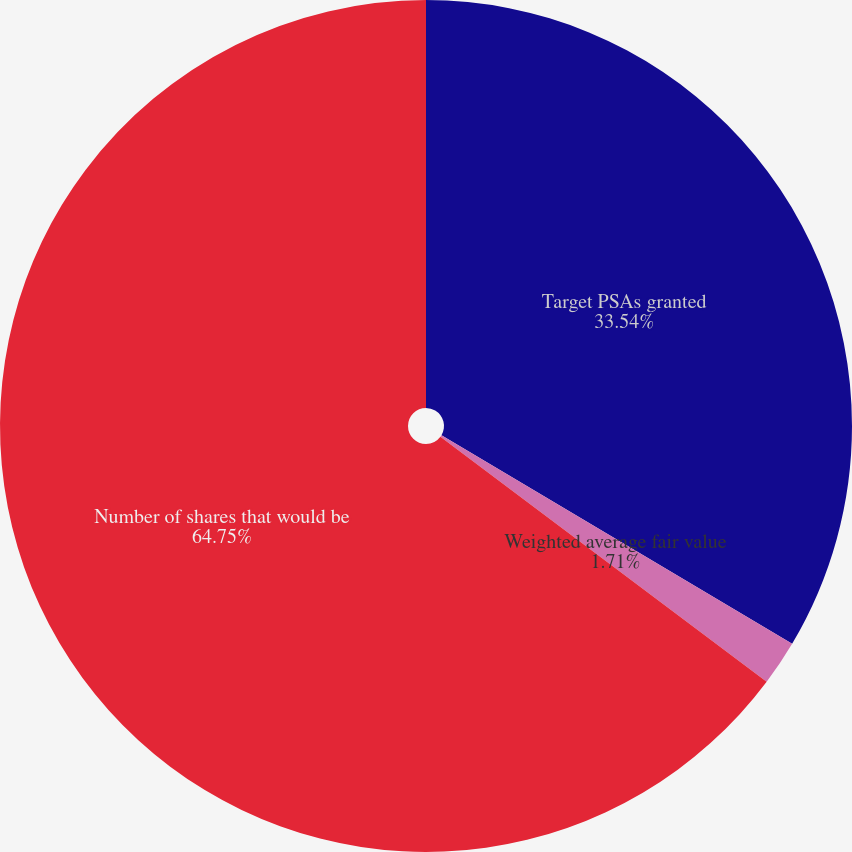Convert chart. <chart><loc_0><loc_0><loc_500><loc_500><pie_chart><fcel>Target PSAs granted<fcel>Weighted average fair value<fcel>Number of shares that would be<nl><fcel>33.54%<fcel>1.71%<fcel>64.75%<nl></chart> 